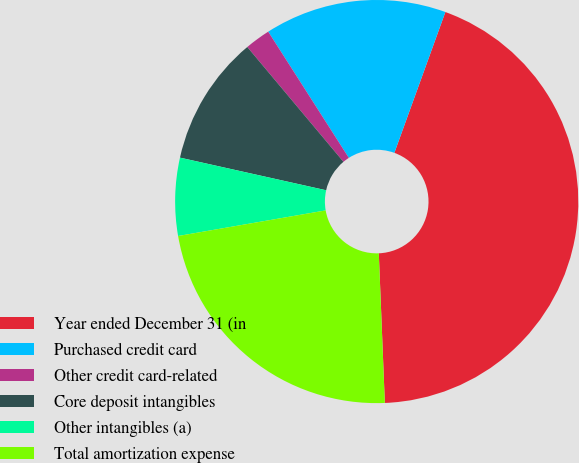<chart> <loc_0><loc_0><loc_500><loc_500><pie_chart><fcel>Year ended December 31 (in<fcel>Purchased credit card<fcel>Other credit card-related<fcel>Core deposit intangibles<fcel>Other intangibles (a)<fcel>Total amortization expense<nl><fcel>43.83%<fcel>14.58%<fcel>2.05%<fcel>10.41%<fcel>6.23%<fcel>22.91%<nl></chart> 